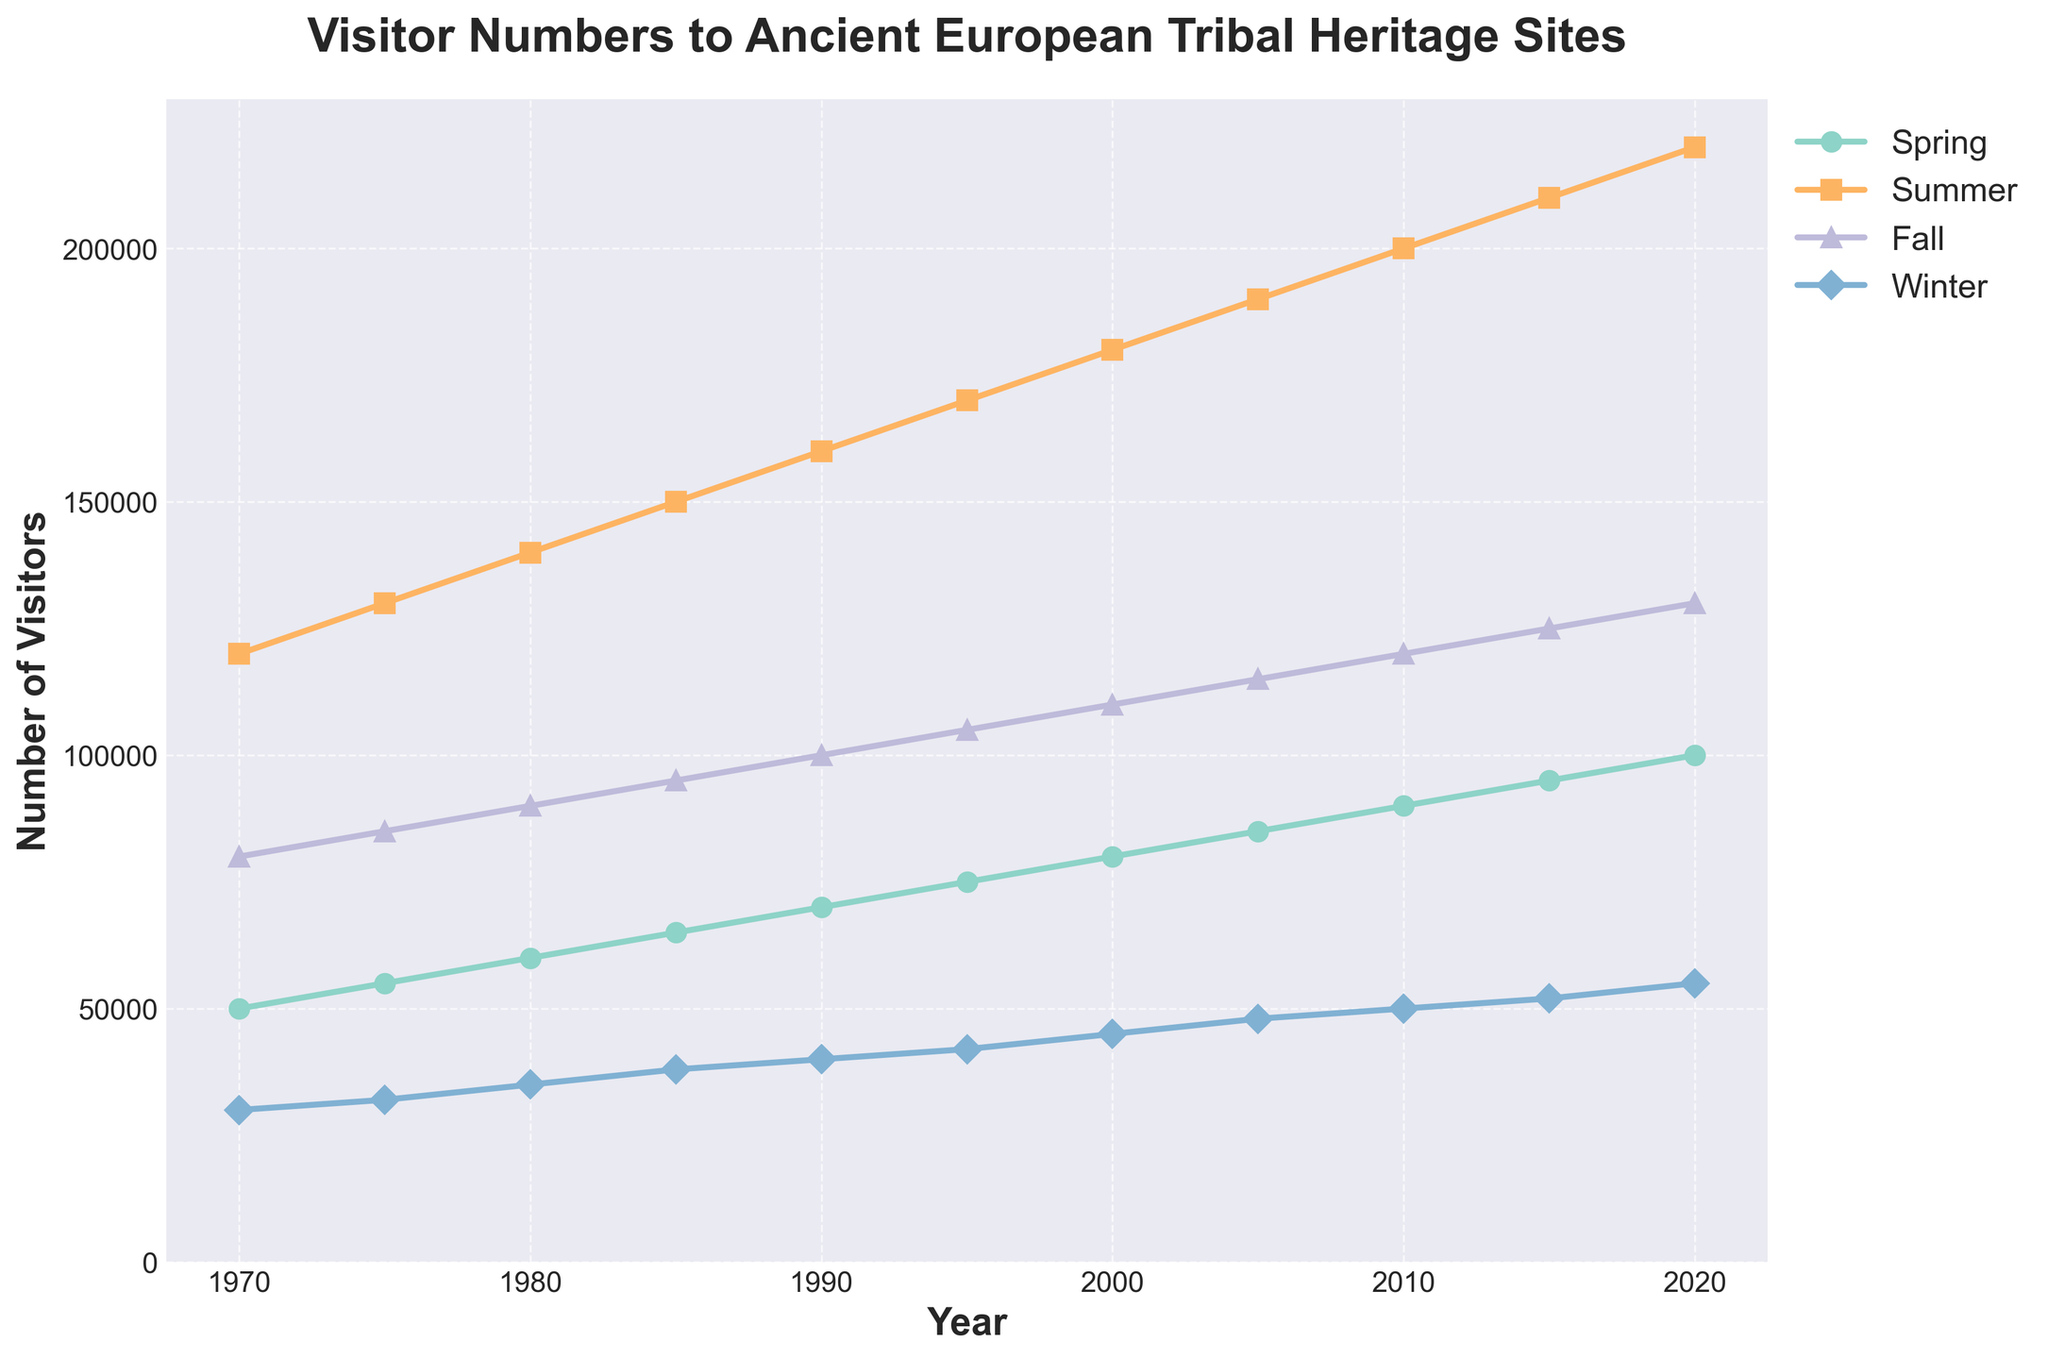What's the trend in visitor numbers for summer over the past 50 years? The trend for summer visitor numbers shows a steady increase from 120,000 in 1970 to 220,000 in 2020. This indicates a general upward trend in summer visitor numbers over the past five decades.
Answer: Steady increase Which season had the highest number of visitors in 2020? In 2020, the summer season had the highest number of visitors, with 220,000 visitors recorded, compared to spring (100,000), fall (130,000), and winter (55,000).
Answer: Summer How does the number of winter visitors in 1990 compare to the number of fall visitors in the same year? In 1990, the number of winter visitors was 40,000, while the number of fall visitors was 100,000. The fall had significantly more visitors than the winter.
Answer: Fall had more visitors What is the average number of visitors in spring across the entire period shown in the chart? To find the average number of spring visitors, sum up the spring visitors for all the years and divide by the number of years (50000 + 55000 + 60000 + 65000 + 70000 + 75000 + 80000 + 85000 + 90000 + 95000 + 100000) / 11. This totals 860,000, and the average is 860,000 / 11 = 78,181.82.
Answer: 78,181.82 Between which consecutive years did summer visitor numbers increase the most? To find the year range with the largest increase, we calculate the differences between consecutive years for summer: 1975-1970 (10,000), 1980-1975 (10,000), 1985-1980 (10,000), 1990-1985 (10,000), 1995-1990 (10,000), 2000-1995 (10,000), 2005-2000 (10,000), 2010-2005 (10,000), 2015-2010 (10,000), 2020-2015 (10,000). The differences are the same, so the increase is consistent.
Answer: Consistent increase of 10,000 Compare the change in visitor numbers between spring and fall from 2000 to 2010. Which season saw a larger increase? The number of spring visitors increased from 80,000 in 2000 to 90,000 in 2010, a change of 10,000. For fall, the numbers increased from 110,000 in 2000 to 120,000 in 2010, a change of 10,000. Both seasons saw the same increase in visitor numbers over this period.
Answer: Same increase What is the difference in visitor numbers between summer and winter in 1985? In 1985, summer had 150,000 visitors and winter had 38,000. The difference is 150,000 - 38,000 = 112,000.
Answer: 112,000 How have fall visitor numbers changed from 1970 to 2020? Fall visitor numbers increased from 80,000 in 1970 to 130,000 in 2020, reflecting a general upward trend over the 50-year period.
Answer: Increased by 50,000 What can you infer about seasonal preferences of visitors based on the trends shown in the chart? The chart shows that summer consistently has the highest number of visitors followed by fall, spring, and winter. This suggests that visitors prefer to visit heritage sites during warmer seasons.
Answer: Preference for warmer seasons 